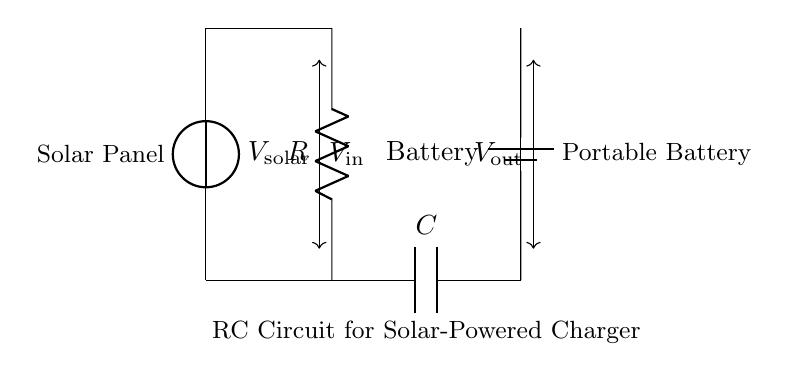What is the input voltage supplied by the solar panel? The input voltage is denoted as V solar in the circuit. This is the voltage supplied by the solar panel to the rest of the circuit.
Answer: V solar What component stores electrical energy in this circuit? The component that stores electrical energy in this circuit is the capacitor, labeled as C. This component is specifically designed to hold charge temporarily.
Answer: Capacitor What is the role of the resistor in this RC circuit? The resistor, labeled as R, is used to limit the current flowing into the capacitor. This function ensures that the charging process occurs at a controlled rate.
Answer: Limit current What is the output component connected to this RC circuit? The output component is the battery, indicated in the diagram and labeled as "Battery." This component receives the energy stored in the capacitor.
Answer: Battery If the value of the resistor is increased, how does it affect the charging time of the capacitor? Increasing the value of the resistor will result in a longer charging time for the capacitor. This is because a higher resistance slows down the current flow, thus taking longer for the capacitor to reach its maximum charge.
Answer: Longer charging time What can be inferred about the function of the battery in this circuit? The battery functions as the energy storage unit that gets charged by the current flowing through the circuit. It provides power to devices when needed, making the whole setup effective for portable charging.
Answer: Energy storage 